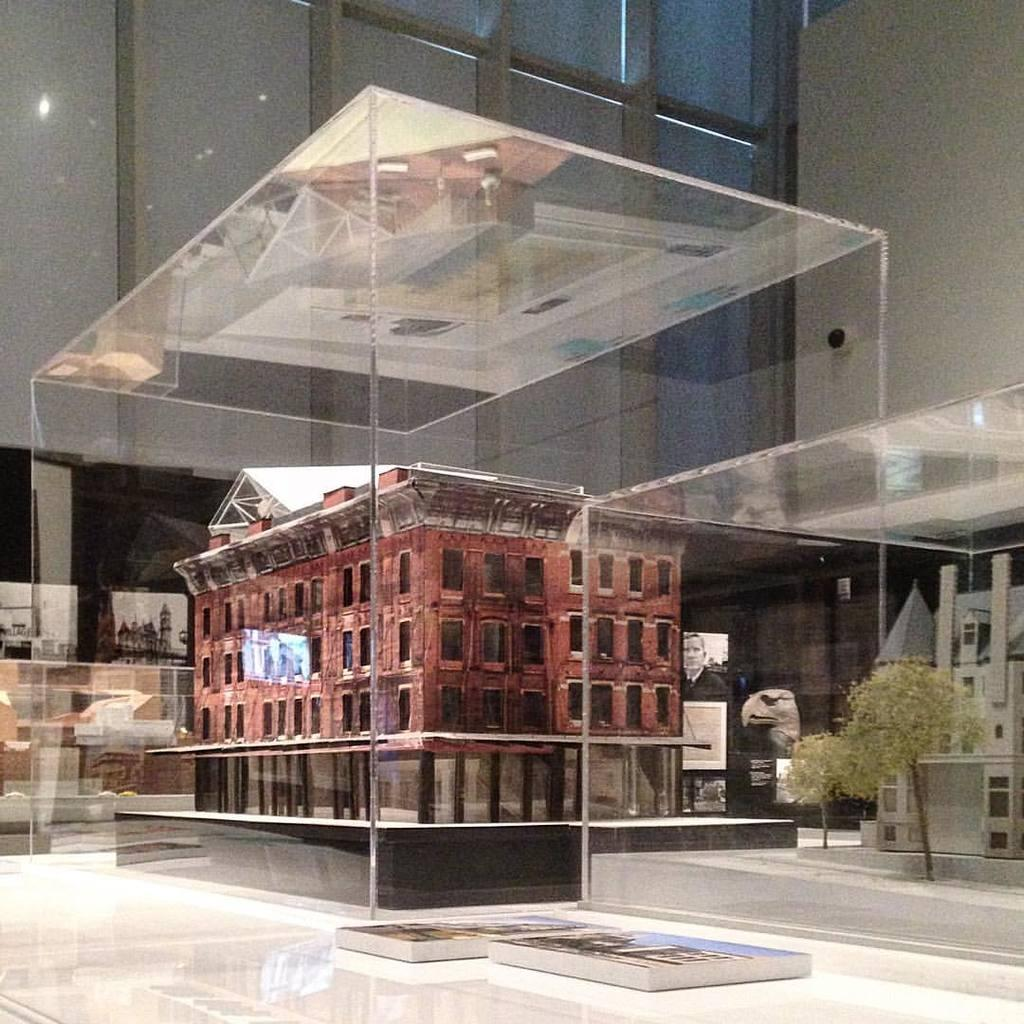What is the main object in the image? There is a glass box present in the image. What is inside the glass box? The glass box contains an architecture of a building. Can you see any crackers inside the glass box? There are no crackers present in the image; it features a glass box containing an architecture of a building. Is the glass box a representation of a jail? The image does not indicate that the glass box is a representation of a jail; it contains an architecture of a building. 